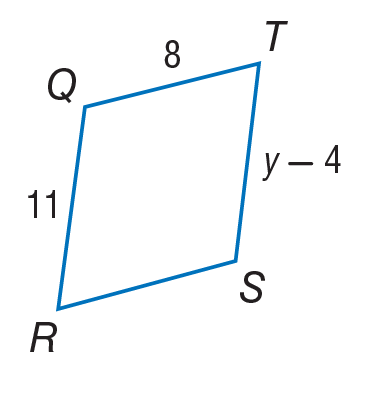Answer the mathemtical geometry problem and directly provide the correct option letter.
Question: Find y in the given parallelogram.
Choices: A: 8 B: 11 C: 15 D: 19 C 